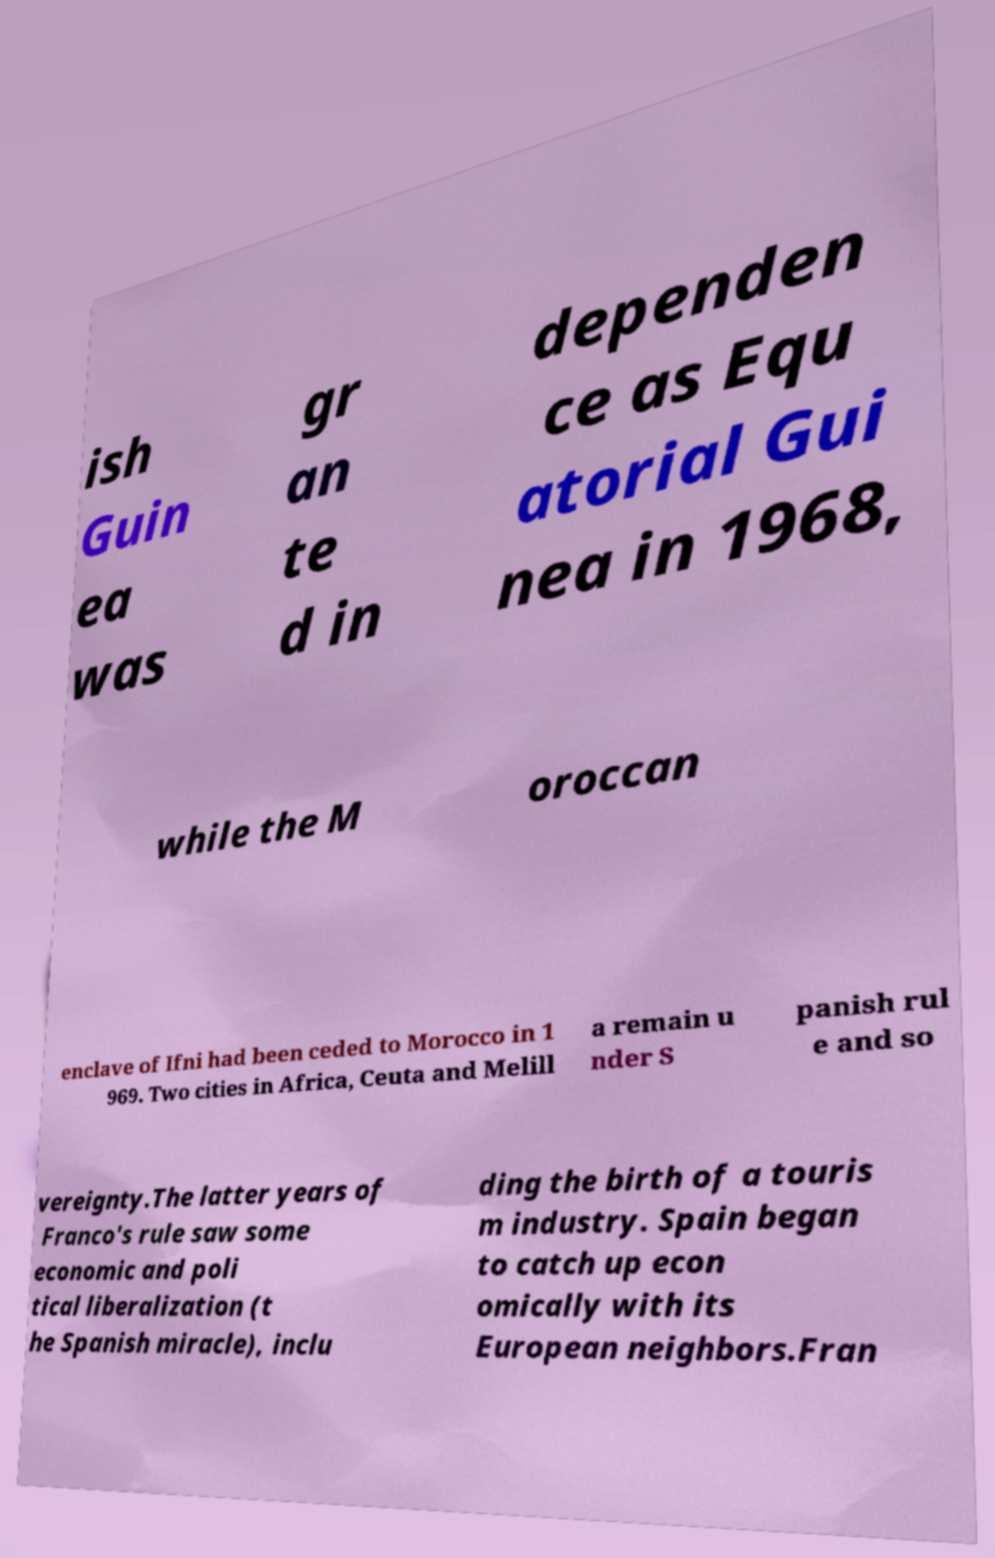Could you extract and type out the text from this image? ish Guin ea was gr an te d in dependen ce as Equ atorial Gui nea in 1968, while the M oroccan enclave of Ifni had been ceded to Morocco in 1 969. Two cities in Africa, Ceuta and Melill a remain u nder S panish rul e and so vereignty.The latter years of Franco's rule saw some economic and poli tical liberalization (t he Spanish miracle), inclu ding the birth of a touris m industry. Spain began to catch up econ omically with its European neighbors.Fran 